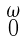<formula> <loc_0><loc_0><loc_500><loc_500>\begin{smallmatrix} \omega \\ 0 \end{smallmatrix}</formula> 